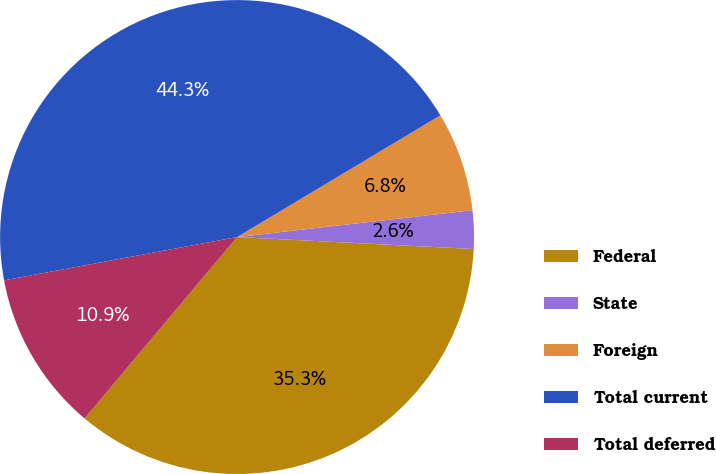Convert chart. <chart><loc_0><loc_0><loc_500><loc_500><pie_chart><fcel>Federal<fcel>State<fcel>Foreign<fcel>Total current<fcel>Total deferred<nl><fcel>35.32%<fcel>2.61%<fcel>6.78%<fcel>44.34%<fcel>10.95%<nl></chart> 